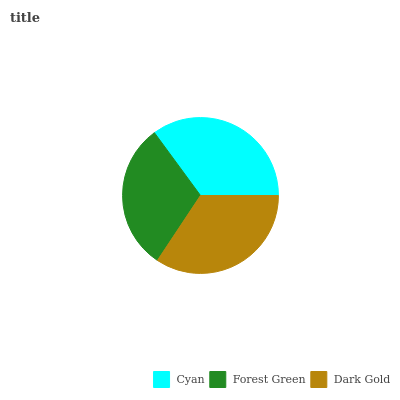Is Forest Green the minimum?
Answer yes or no. Yes. Is Cyan the maximum?
Answer yes or no. Yes. Is Dark Gold the minimum?
Answer yes or no. No. Is Dark Gold the maximum?
Answer yes or no. No. Is Dark Gold greater than Forest Green?
Answer yes or no. Yes. Is Forest Green less than Dark Gold?
Answer yes or no. Yes. Is Forest Green greater than Dark Gold?
Answer yes or no. No. Is Dark Gold less than Forest Green?
Answer yes or no. No. Is Dark Gold the high median?
Answer yes or no. Yes. Is Dark Gold the low median?
Answer yes or no. Yes. Is Cyan the high median?
Answer yes or no. No. Is Cyan the low median?
Answer yes or no. No. 